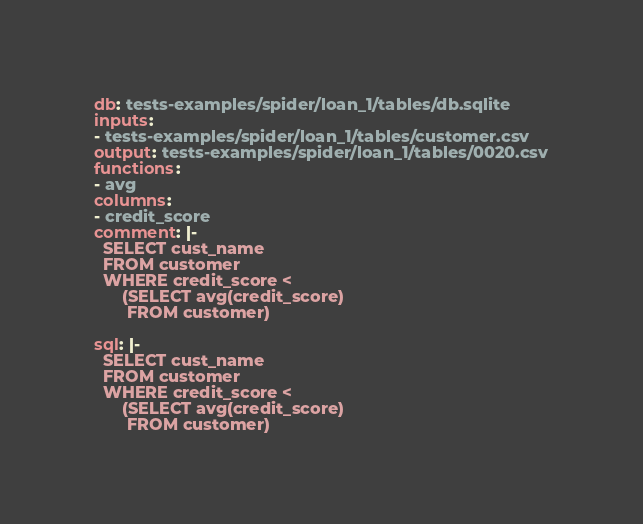<code> <loc_0><loc_0><loc_500><loc_500><_YAML_>db: tests-examples/spider/loan_1/tables/db.sqlite
inputs:
- tests-examples/spider/loan_1/tables/customer.csv
output: tests-examples/spider/loan_1/tables/0020.csv
functions:
- avg
columns:
- credit_score
comment: |-
  SELECT cust_name
  FROM customer
  WHERE credit_score <
      (SELECT avg(credit_score)
       FROM customer)

sql: |-
  SELECT cust_name
  FROM customer
  WHERE credit_score <
      (SELECT avg(credit_score)
       FROM customer)</code> 